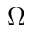<formula> <loc_0><loc_0><loc_500><loc_500>\Omega</formula> 